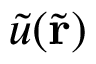<formula> <loc_0><loc_0><loc_500><loc_500>\tilde { u } ( \tilde { r } )</formula> 